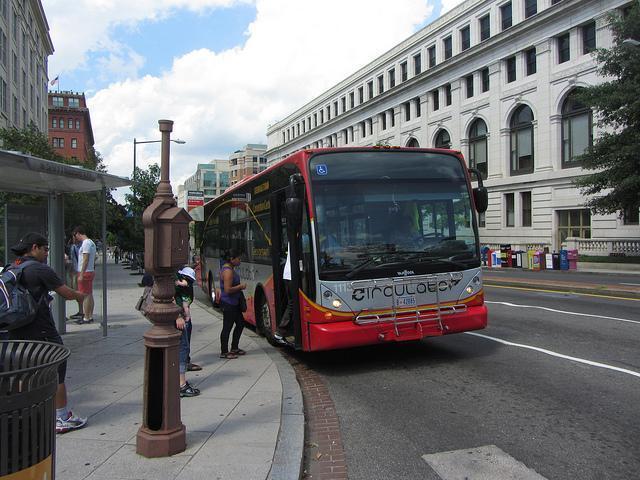How many people are there?
Give a very brief answer. 2. How many cups on the table are empty?
Give a very brief answer. 0. 